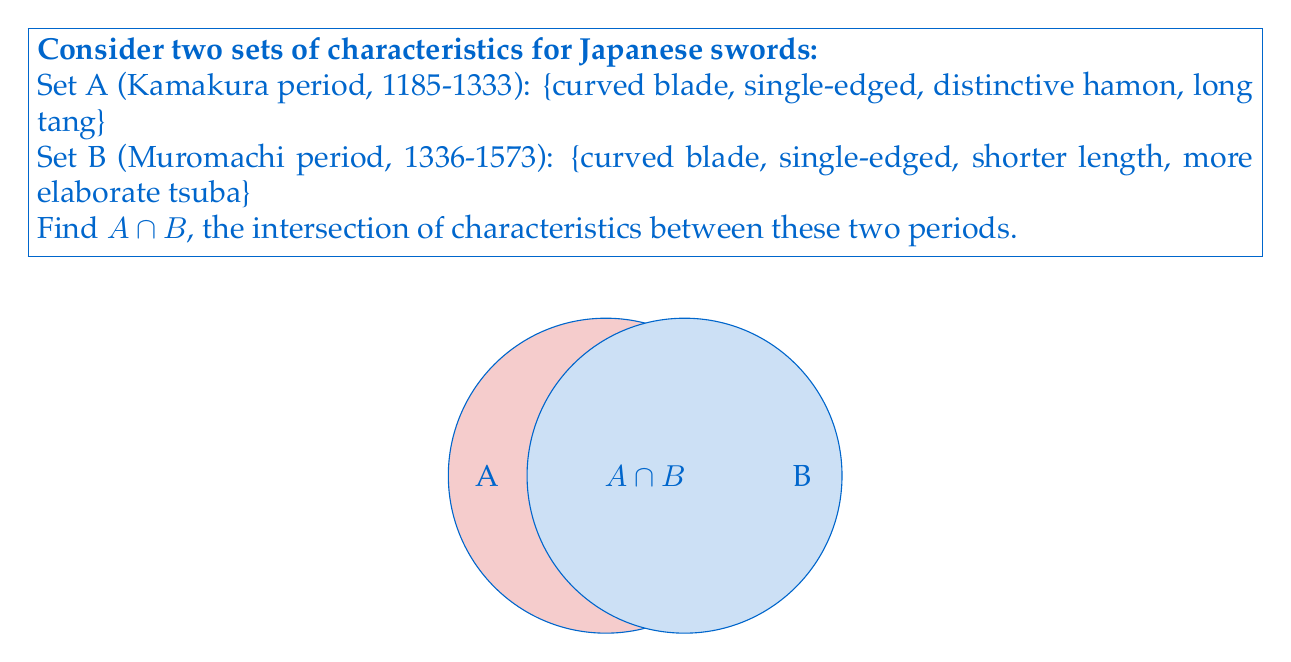Help me with this question. To find the intersection of two sets, we need to identify the elements that are common to both sets. Let's approach this step-by-step:

1) First, let's list out the elements of each set:
   Set A = {curved blade, single-edged, distinctive hamon, long tang}
   Set B = {curved blade, single-edged, shorter length, more elaborate tsuba}

2) Now, we need to identify which elements appear in both sets:
   - "curved blade" appears in both A and B
   - "single-edged" appears in both A and B
   - "distinctive hamon" only appears in A
   - "long tang" only appears in A
   - "shorter length" only appears in B
   - "more elaborate tsuba" only appears in B

3) The intersection $A \cap B$ contains only the elements that appear in both sets.

4) Therefore, $A \cap B = \{curved blade, single-edged\}$

This result shows that despite the differences between the Kamakura and Muromachi periods, some fundamental characteristics of Japanese swords remained consistent.
Answer: $A \cap B = \{curved blade, single-edged\}$ 